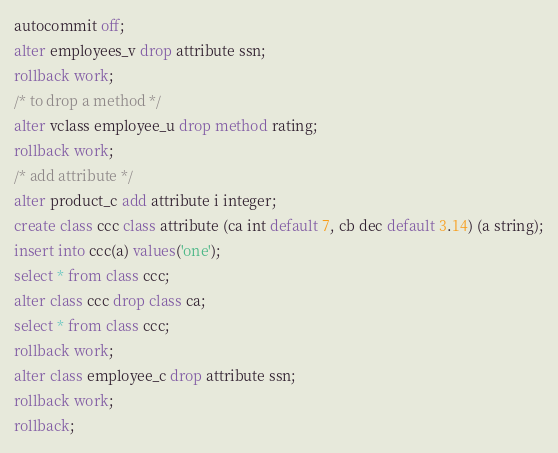Convert code to text. <code><loc_0><loc_0><loc_500><loc_500><_SQL_>autocommit off;
alter employees_v drop attribute ssn;
rollback work;
/* to drop a method */
alter vclass employee_u drop method rating;
rollback work;
/* add attribute */
alter product_c add attribute i integer;
create class ccc class attribute (ca int default 7, cb dec default 3.14) (a string);
insert into ccc(a) values('one');
select * from class ccc;
alter class ccc drop class ca;
select * from class ccc;
rollback work;
alter class employee_c drop attribute ssn;
rollback work;
rollback;
</code> 